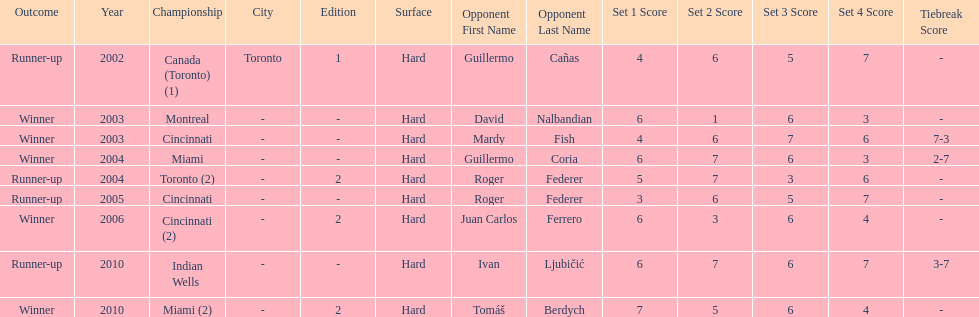How many consecutive years was there a hard surface at the championship? 9. 